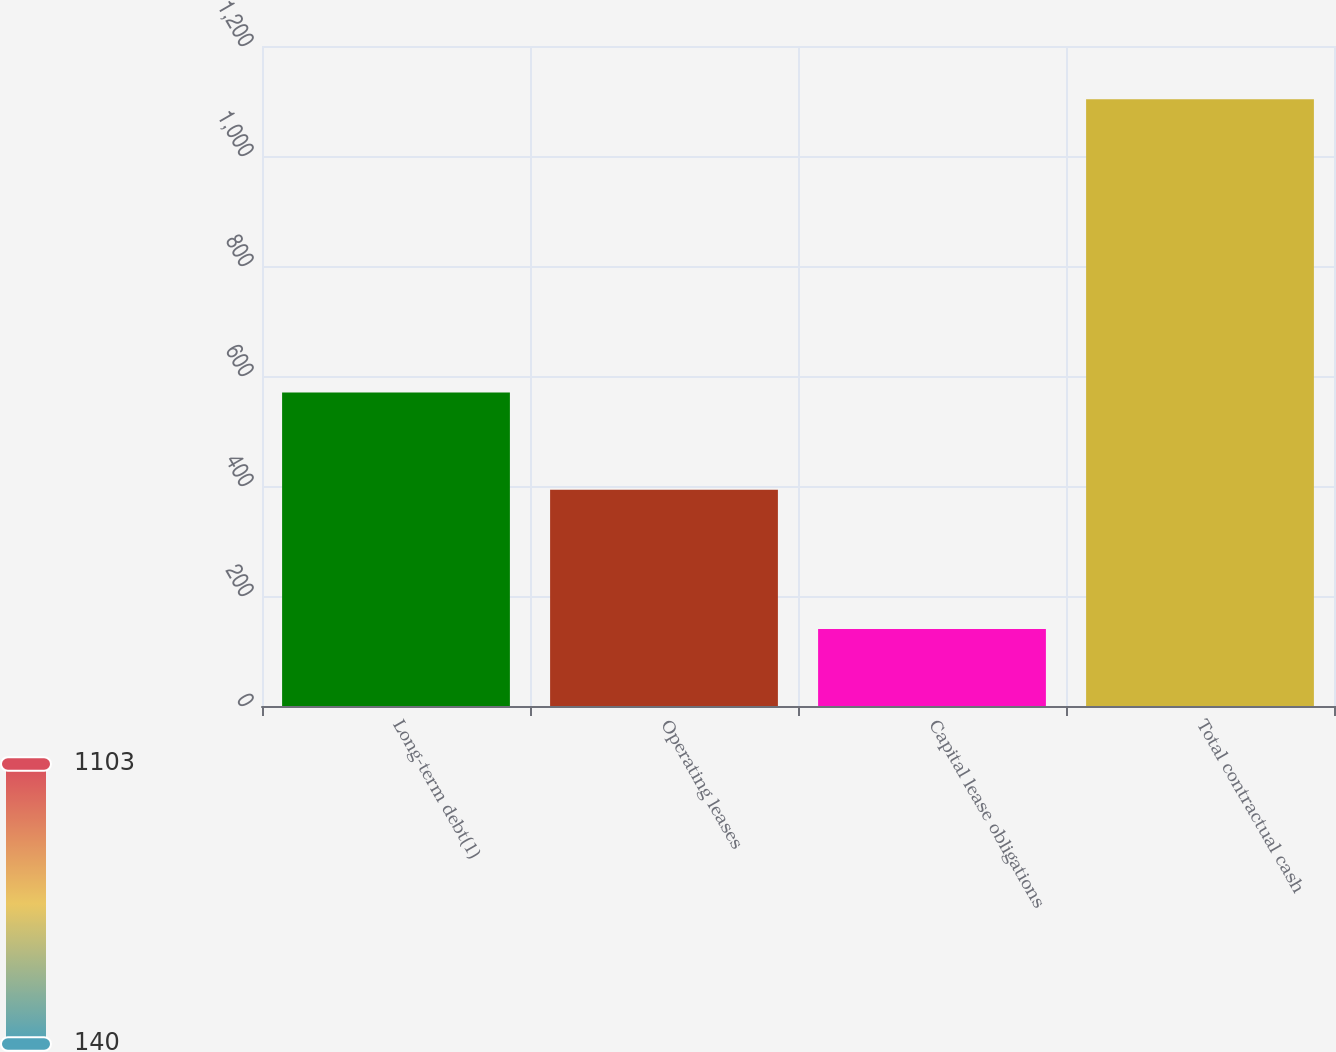<chart> <loc_0><loc_0><loc_500><loc_500><bar_chart><fcel>Long-term debt(1)<fcel>Operating leases<fcel>Capital lease obligations<fcel>Total contractual cash<nl><fcel>570<fcel>393<fcel>140<fcel>1103<nl></chart> 